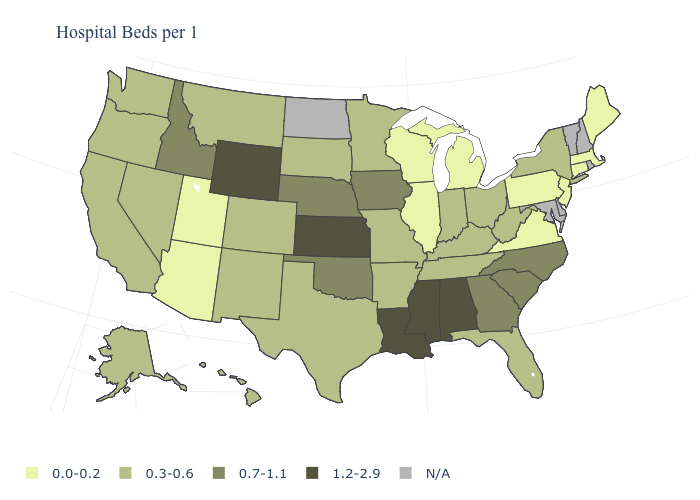What is the lowest value in states that border Kansas?
Answer briefly. 0.3-0.6. Which states have the lowest value in the USA?
Short answer required. Arizona, Connecticut, Illinois, Maine, Massachusetts, Michigan, New Jersey, Pennsylvania, Utah, Virginia, Wisconsin. What is the value of Rhode Island?
Answer briefly. N/A. Does Wyoming have the highest value in the West?
Concise answer only. Yes. Does Nebraska have the highest value in the USA?
Be succinct. No. Does the first symbol in the legend represent the smallest category?
Concise answer only. Yes. Name the states that have a value in the range 0.7-1.1?
Keep it brief. Georgia, Idaho, Iowa, Nebraska, North Carolina, Oklahoma, South Carolina. Name the states that have a value in the range 0.3-0.6?
Be succinct. Alaska, Arkansas, California, Colorado, Florida, Hawaii, Indiana, Kentucky, Minnesota, Missouri, Montana, Nevada, New Mexico, New York, Ohio, Oregon, South Dakota, Tennessee, Texas, Washington, West Virginia. What is the lowest value in the South?
Quick response, please. 0.0-0.2. Name the states that have a value in the range 0.3-0.6?
Answer briefly. Alaska, Arkansas, California, Colorado, Florida, Hawaii, Indiana, Kentucky, Minnesota, Missouri, Montana, Nevada, New Mexico, New York, Ohio, Oregon, South Dakota, Tennessee, Texas, Washington, West Virginia. Which states have the lowest value in the Northeast?
Give a very brief answer. Connecticut, Maine, Massachusetts, New Jersey, Pennsylvania. Name the states that have a value in the range 0.0-0.2?
Short answer required. Arizona, Connecticut, Illinois, Maine, Massachusetts, Michigan, New Jersey, Pennsylvania, Utah, Virginia, Wisconsin. What is the value of Louisiana?
Be succinct. 1.2-2.9. Which states have the highest value in the USA?
Write a very short answer. Alabama, Kansas, Louisiana, Mississippi, Wyoming. Name the states that have a value in the range 0.7-1.1?
Write a very short answer. Georgia, Idaho, Iowa, Nebraska, North Carolina, Oklahoma, South Carolina. 